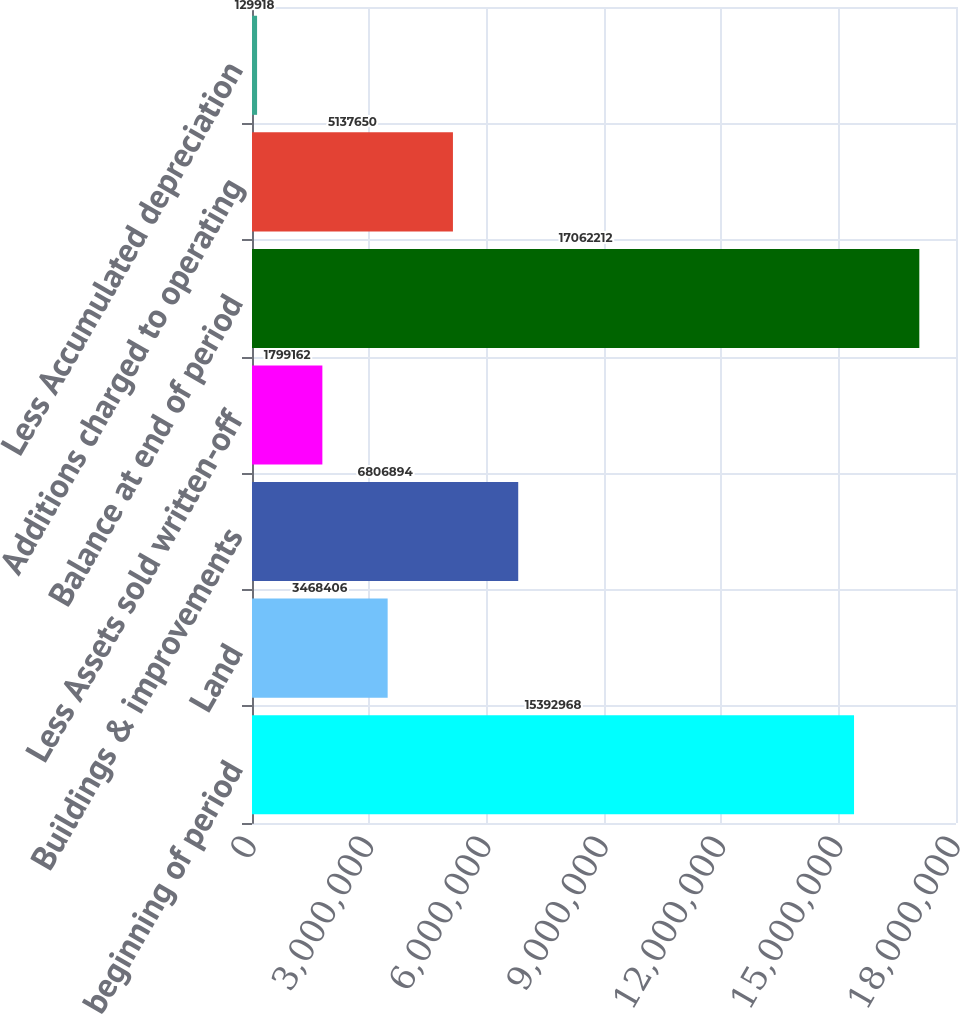<chart> <loc_0><loc_0><loc_500><loc_500><bar_chart><fcel>Balance at beginning of period<fcel>Land<fcel>Buildings & improvements<fcel>Less Assets sold written-off<fcel>Balance at end of period<fcel>Additions charged to operating<fcel>Less Accumulated depreciation<nl><fcel>1.5393e+07<fcel>3.46841e+06<fcel>6.80689e+06<fcel>1.79916e+06<fcel>1.70622e+07<fcel>5.13765e+06<fcel>129918<nl></chart> 